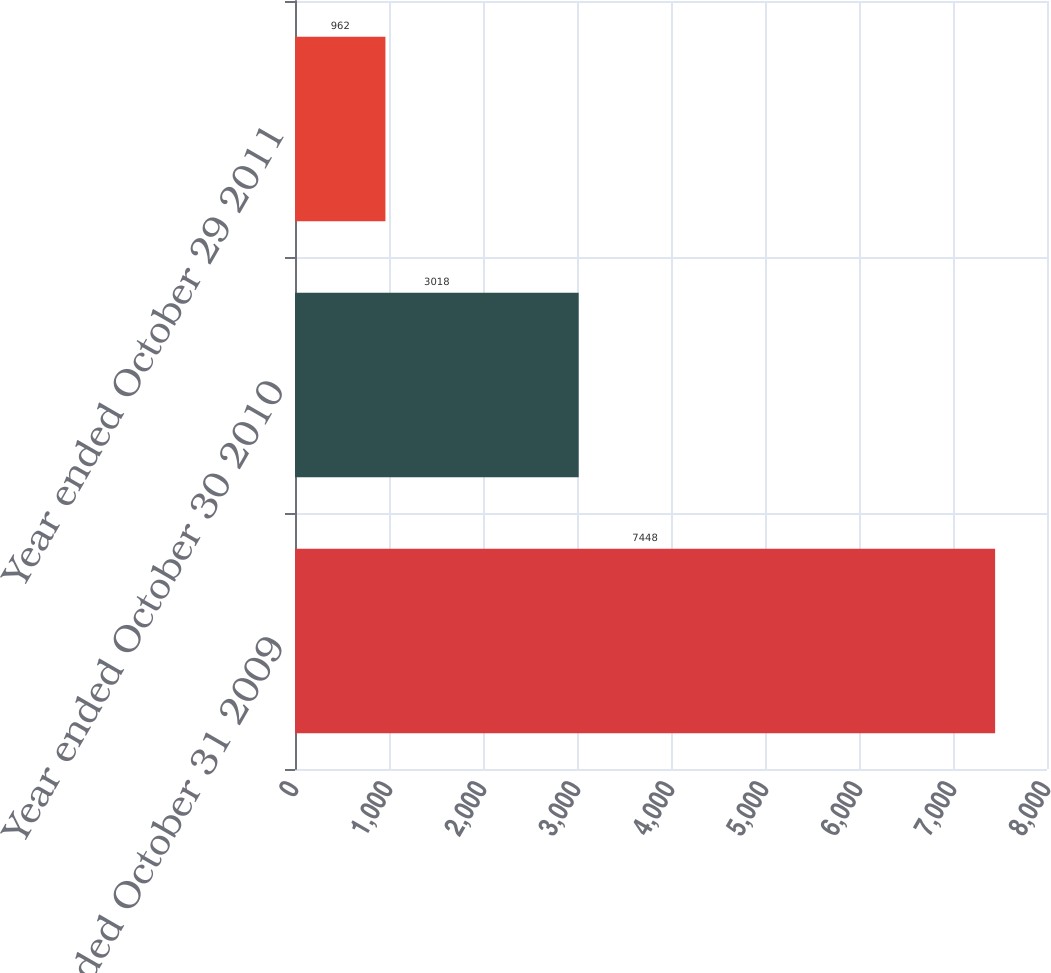<chart> <loc_0><loc_0><loc_500><loc_500><bar_chart><fcel>Year ended October 31 2009<fcel>Year ended October 30 2010<fcel>Year ended October 29 2011<nl><fcel>7448<fcel>3018<fcel>962<nl></chart> 